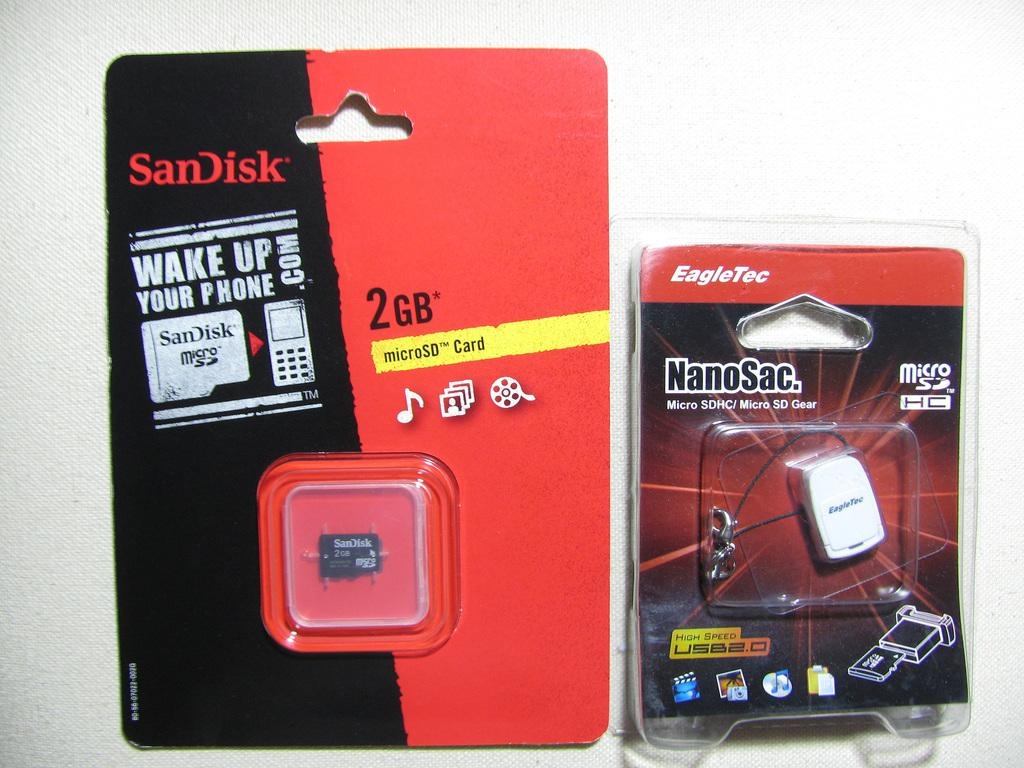<image>
Describe the image concisely. Sandisk microSD card in its packaging is on the left of EagelTec nanosac in its packaging. 